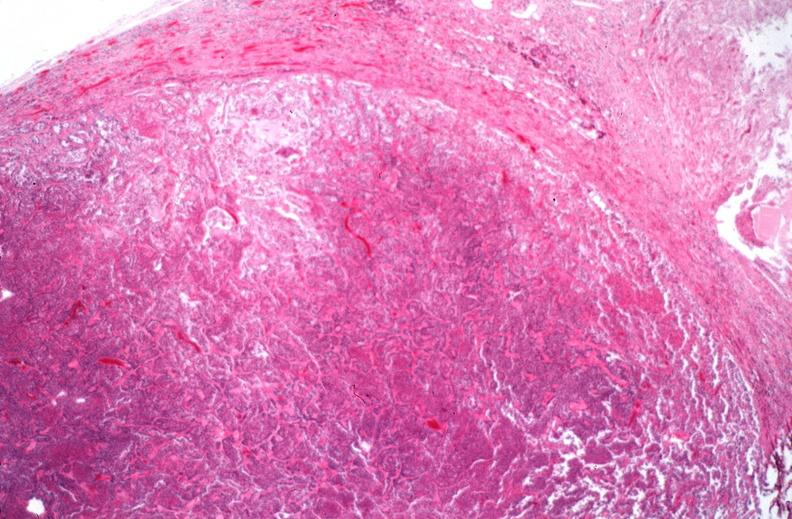what is present?
Answer the question using a single word or phrase. Endocrine 